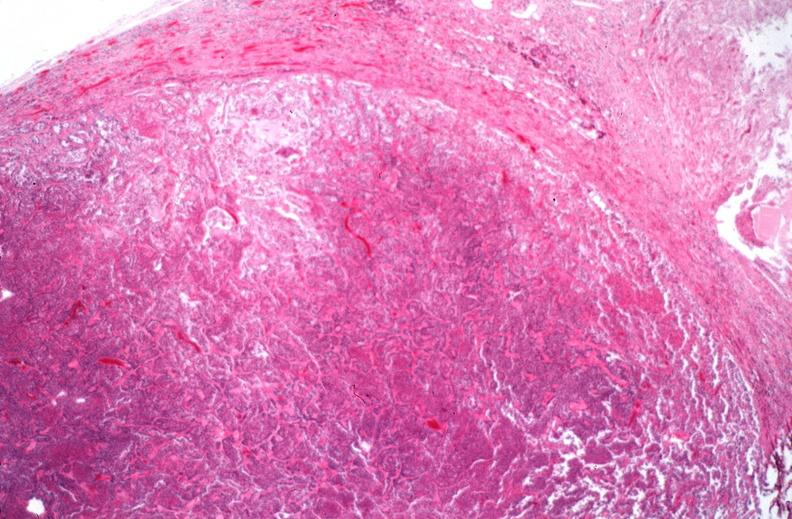what is present?
Answer the question using a single word or phrase. Endocrine 